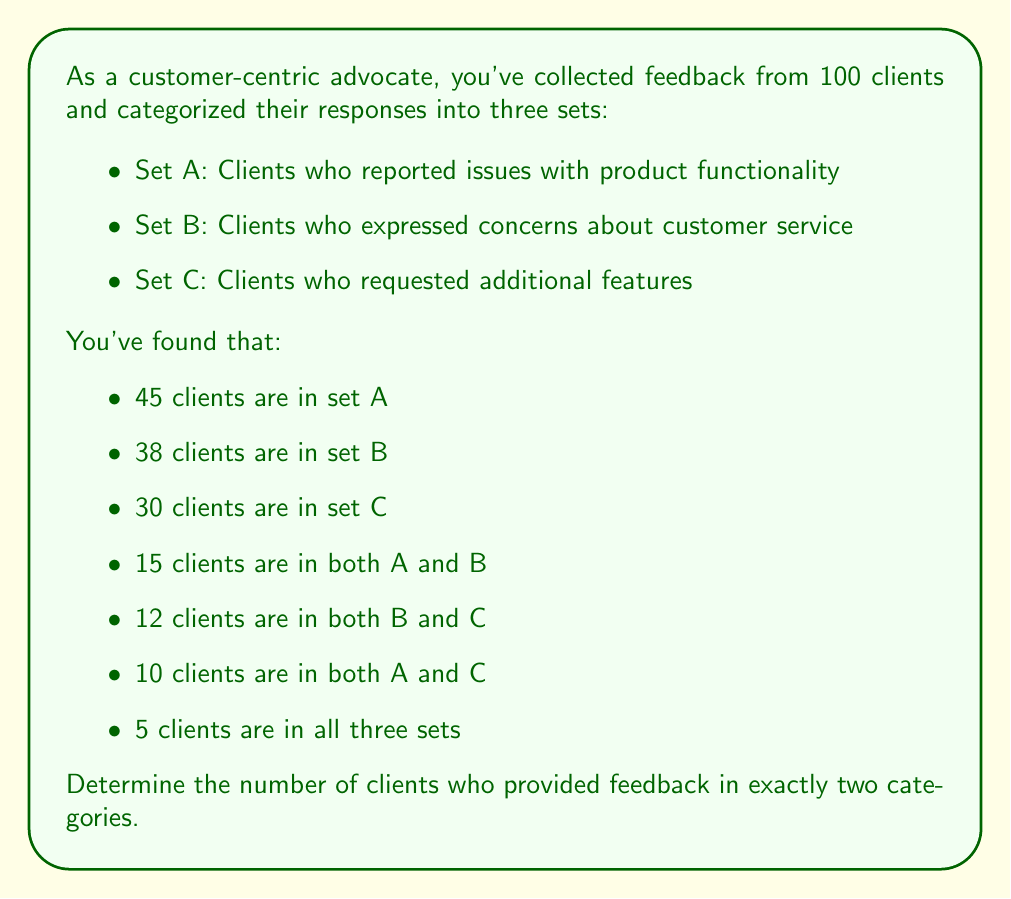Provide a solution to this math problem. To solve this problem, we'll use the principle of inclusion-exclusion and set theory concepts.

1. Let's define $|A \cap B \cap C|$ as the number of clients in all three sets, which is 5.

2. We need to find the number of clients in exactly two categories. This can be calculated by:
   $|(A \cap B) \setminus C| + |(B \cap C) \setminus A| + |(A \cap C) \setminus B|$

3. To find these values:
   $|(A \cap B) \setminus C| = |A \cap B| - |A \cap B \cap C| = 15 - 5 = 10$
   $|(B \cap C) \setminus A| = |B \cap C| - |A \cap B \cap C| = 12 - 5 = 7$
   $|(A \cap C) \setminus B| = |A \cap C| - |A \cap B \cap C| = 10 - 5 = 5$

4. Sum these values:
   $10 + 7 + 5 = 22$

Therefore, 22 clients provided feedback in exactly two categories.
Answer: 22 clients 